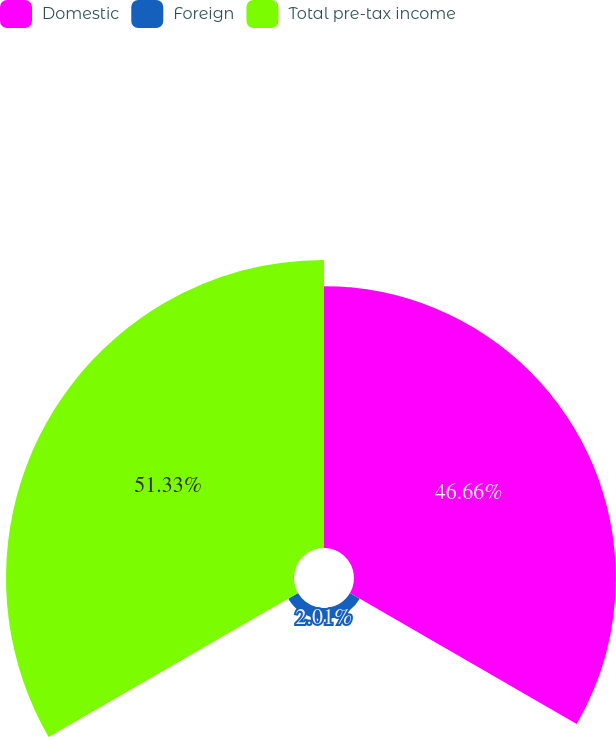<chart> <loc_0><loc_0><loc_500><loc_500><pie_chart><fcel>Domestic<fcel>Foreign<fcel>Total pre-tax income<nl><fcel>46.66%<fcel>2.01%<fcel>51.33%<nl></chart> 